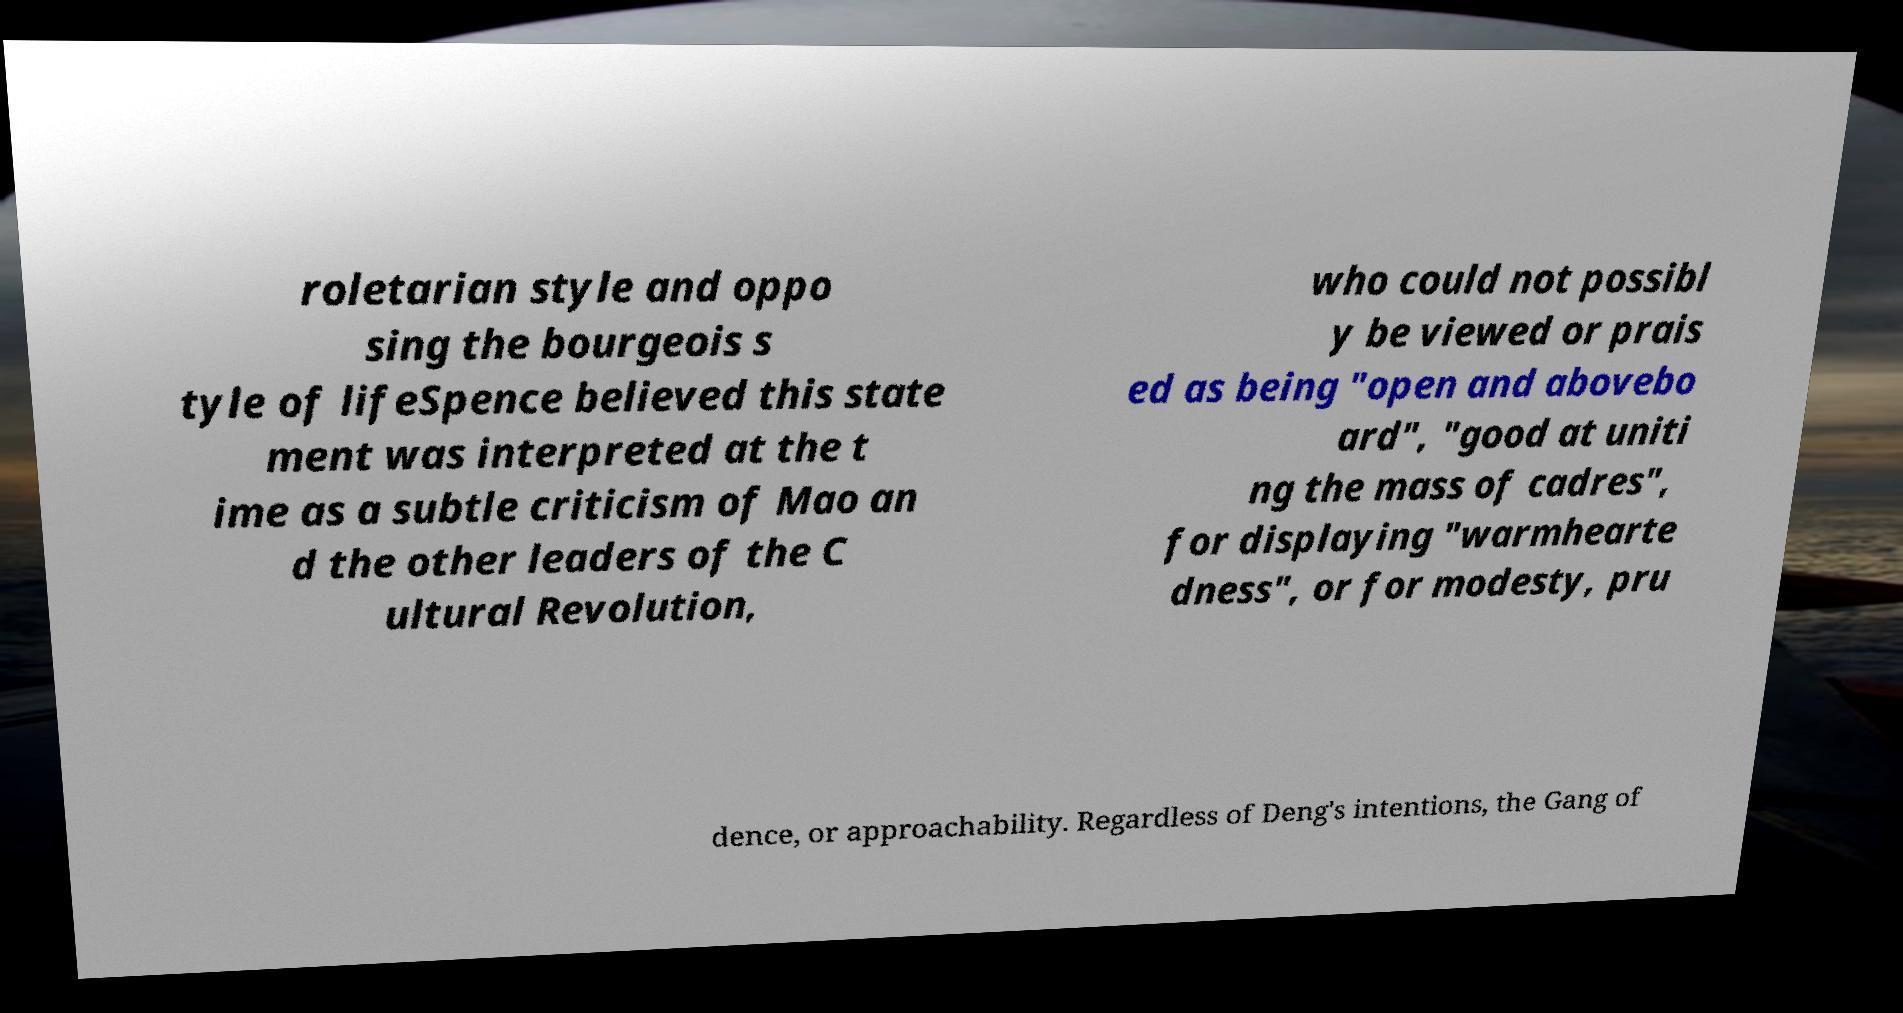Can you accurately transcribe the text from the provided image for me? roletarian style and oppo sing the bourgeois s tyle of lifeSpence believed this state ment was interpreted at the t ime as a subtle criticism of Mao an d the other leaders of the C ultural Revolution, who could not possibl y be viewed or prais ed as being "open and abovebo ard", "good at uniti ng the mass of cadres", for displaying "warmhearte dness", or for modesty, pru dence, or approachability. Regardless of Deng's intentions, the Gang of 